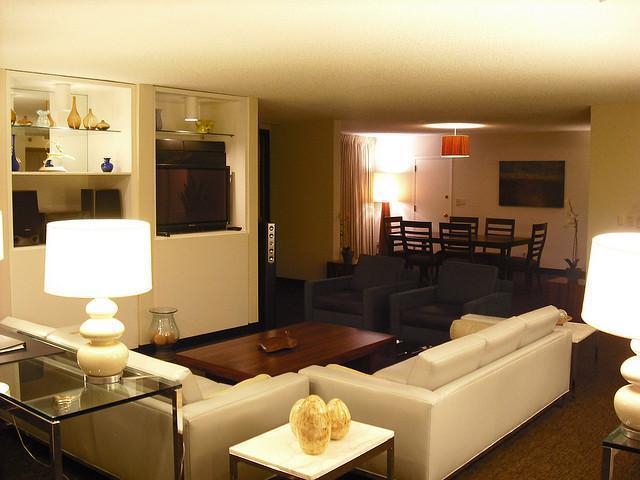How many couches can be seen?
Give a very brief answer. 2. 